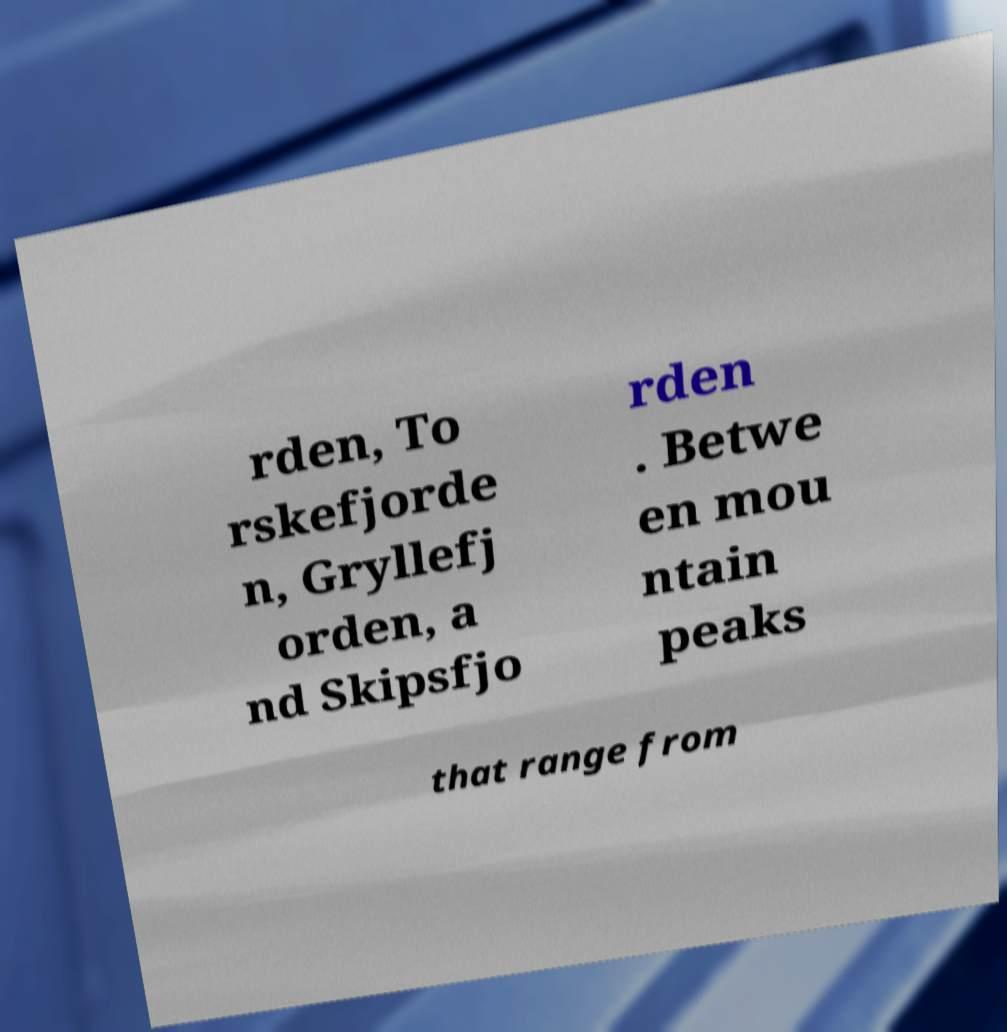Can you accurately transcribe the text from the provided image for me? rden, To rskefjorde n, Gryllefj orden, a nd Skipsfjo rden . Betwe en mou ntain peaks that range from 